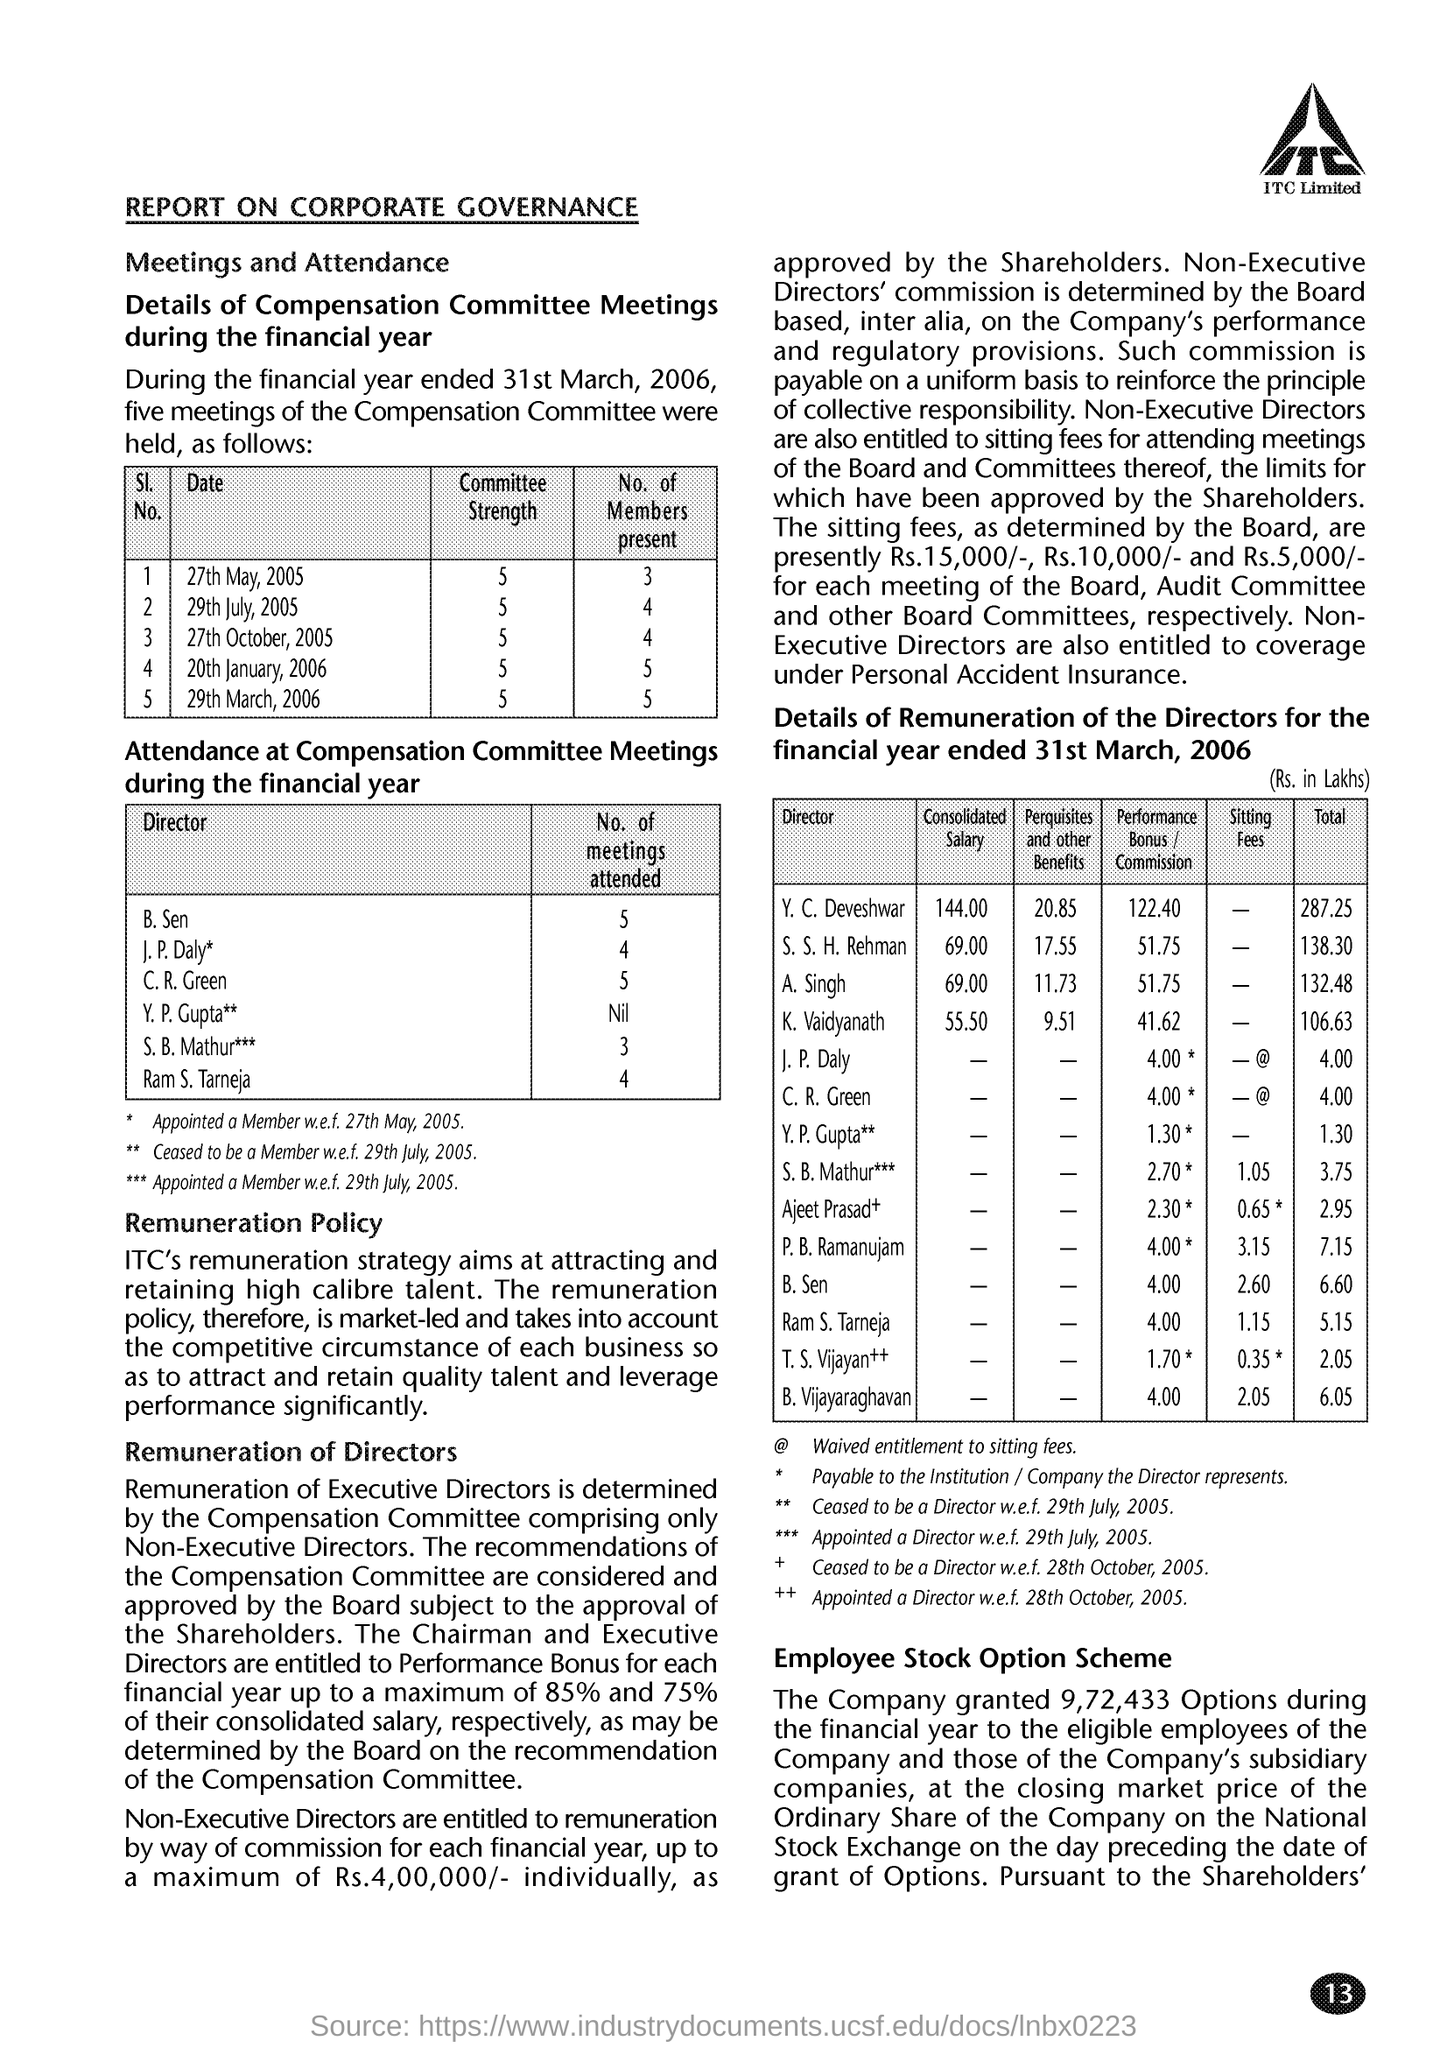Outline some significant characteristics in this image. The report pertains to the topic of corporate governance. The remuneration strategy of ITC, which aims to attract and retain high-caliber talent, is a prominent feature of the organization. 